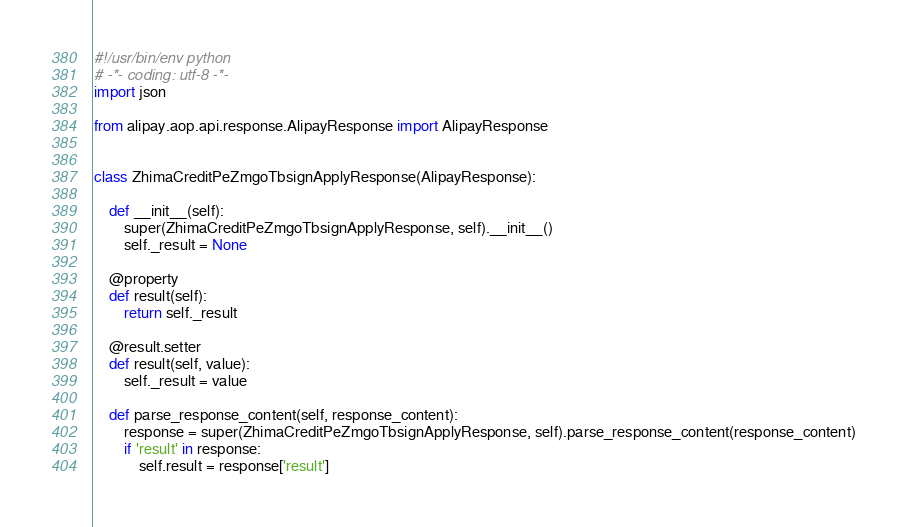Convert code to text. <code><loc_0><loc_0><loc_500><loc_500><_Python_>#!/usr/bin/env python
# -*- coding: utf-8 -*-
import json

from alipay.aop.api.response.AlipayResponse import AlipayResponse


class ZhimaCreditPeZmgoTbsignApplyResponse(AlipayResponse):

    def __init__(self):
        super(ZhimaCreditPeZmgoTbsignApplyResponse, self).__init__()
        self._result = None

    @property
    def result(self):
        return self._result

    @result.setter
    def result(self, value):
        self._result = value

    def parse_response_content(self, response_content):
        response = super(ZhimaCreditPeZmgoTbsignApplyResponse, self).parse_response_content(response_content)
        if 'result' in response:
            self.result = response['result']
</code> 